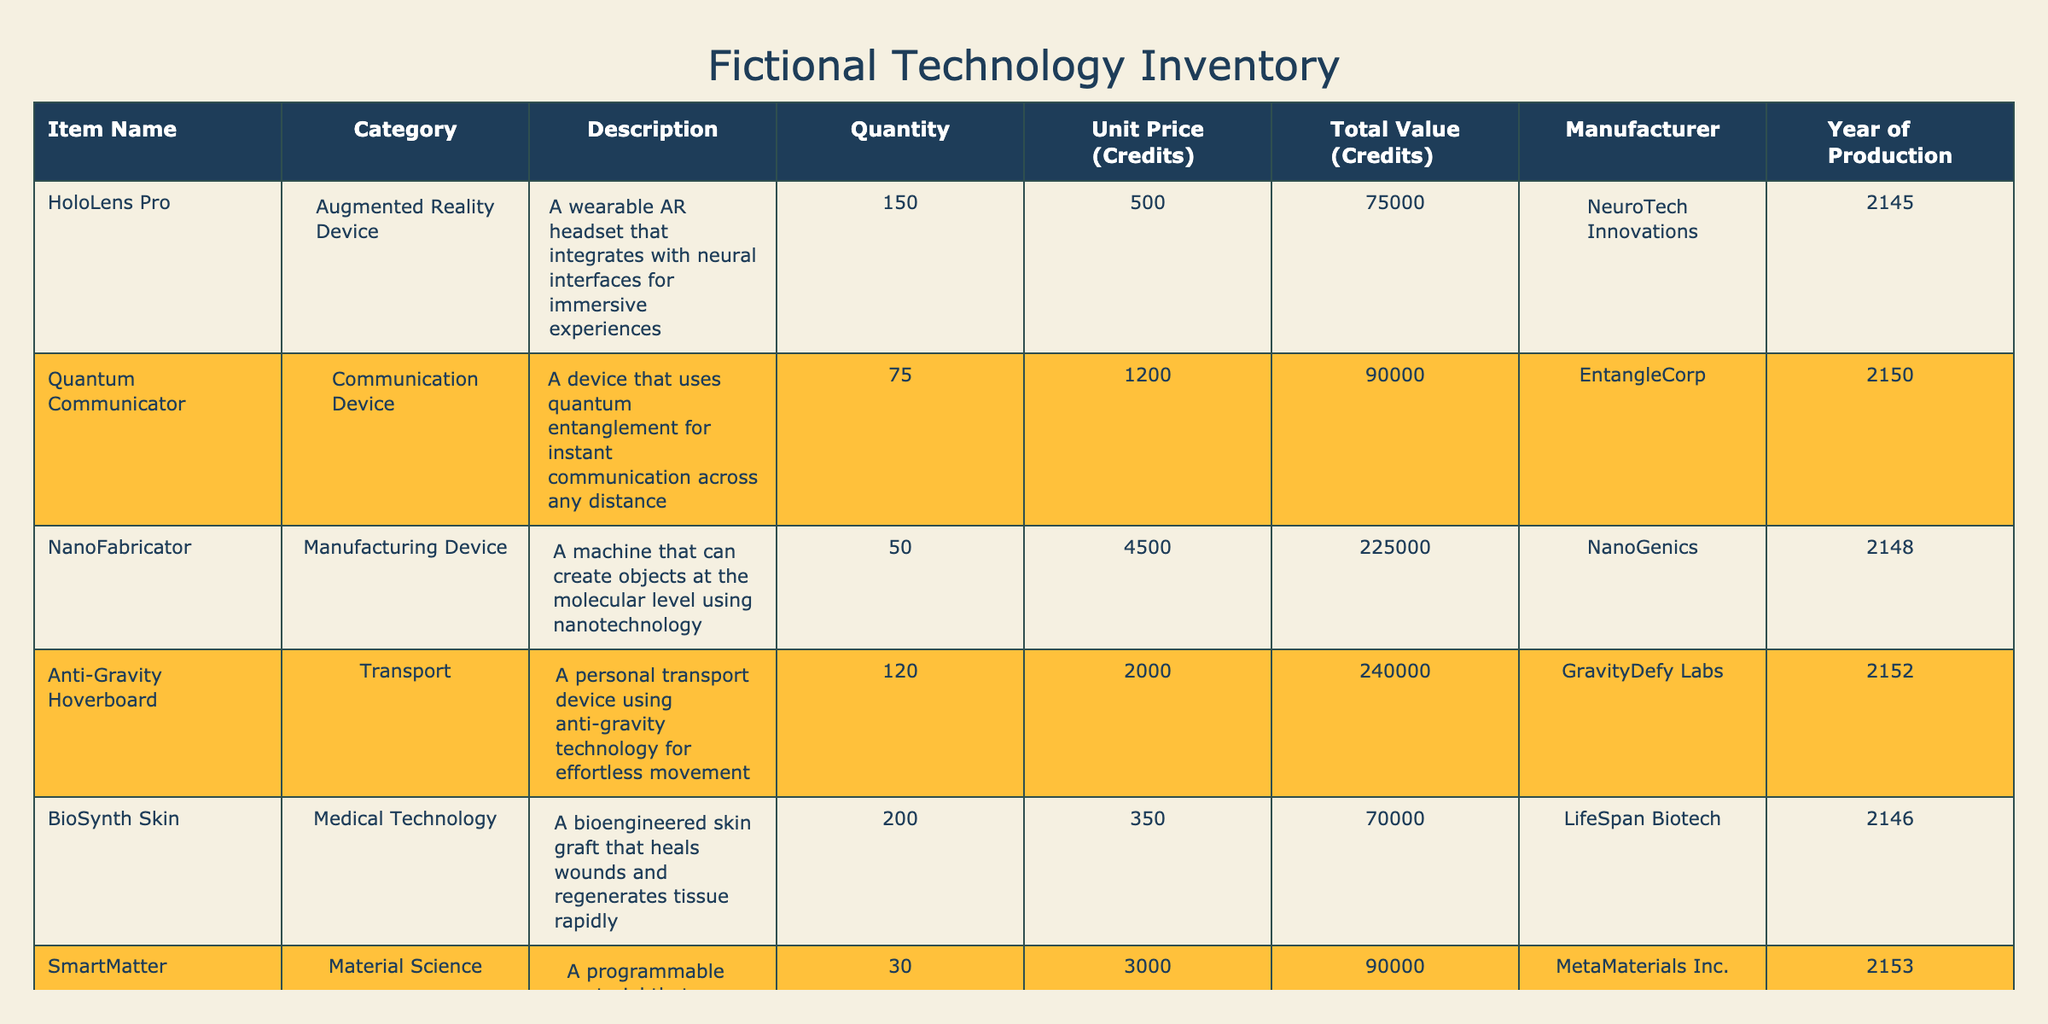What is the total value of the Anti-Gravity Hoverboard? The total value for one unit of the Anti-Gravity Hoverboard is listed in the "Total Value (Credits)" column. According to the table, it is 240,000 Credits.
Answer: 240000 How many Quantum Communicators are available? The quantity of Quantum Communicators available can be found in the "Quantity" column. The table indicates there are 75 available.
Answer: 75 Is there a device that has a total value greater than 300,000 Credits? To answer this, we check the "Total Value (Credits)" column for each item. Only the Self-Repairing Drones has a total value of 320,000 Credits which is greater than 300,000.
Answer: Yes What is the average unit price of all items in the inventory? First, add up all the unit prices: (500 + 1200 + 4500 + 2000 + 350 + 3000 + 1500 + 10000 + 8000 + 50000) = 100,000. There are 10 items, so the average is 100,000/10 = 10,000.
Answer: 10000 How many more BioSynth Skins are there than SmartMatter? The quantity of BioSynth Skin is 200, while SmartMatter has 30. Calculate the difference: 200 - 30 = 170.
Answer: 170 What percentage of the total inventory value does the NanoFabricator represent? First, calculate the total value of the whole inventory by summing all "Total Value (Credits)" values, which is 1,840,000. The value of the NanoFabricator is 225,000. Now, calculate the percentage: (225,000 / 1,840,000) * 100 = 12.24%.
Answer: 12.24% Are there more than 100 units of medical technology in the inventory? To answer this, sum the quantities of all medical-related devices, which are BioSynth Skin (200). Since 200 is greater than 100, the answer is yes.
Answer: Yes Which item has the highest unit price and what is that price? The item with the highest unit price can be determined by looking at the "Unit Price (Credits)" column. The Genetic Enhancer has the highest unit price of 10,000 Credits.
Answer: 10000 Is the total value of the Hyperloop Transit Pod lower than any other item's total value? Evaluate the total value of the Hyperloop Transit Pod, which is 500,000 Credits. Compare this with other items; it is higher than all except the Self-Repairing Drones.
Answer: No 